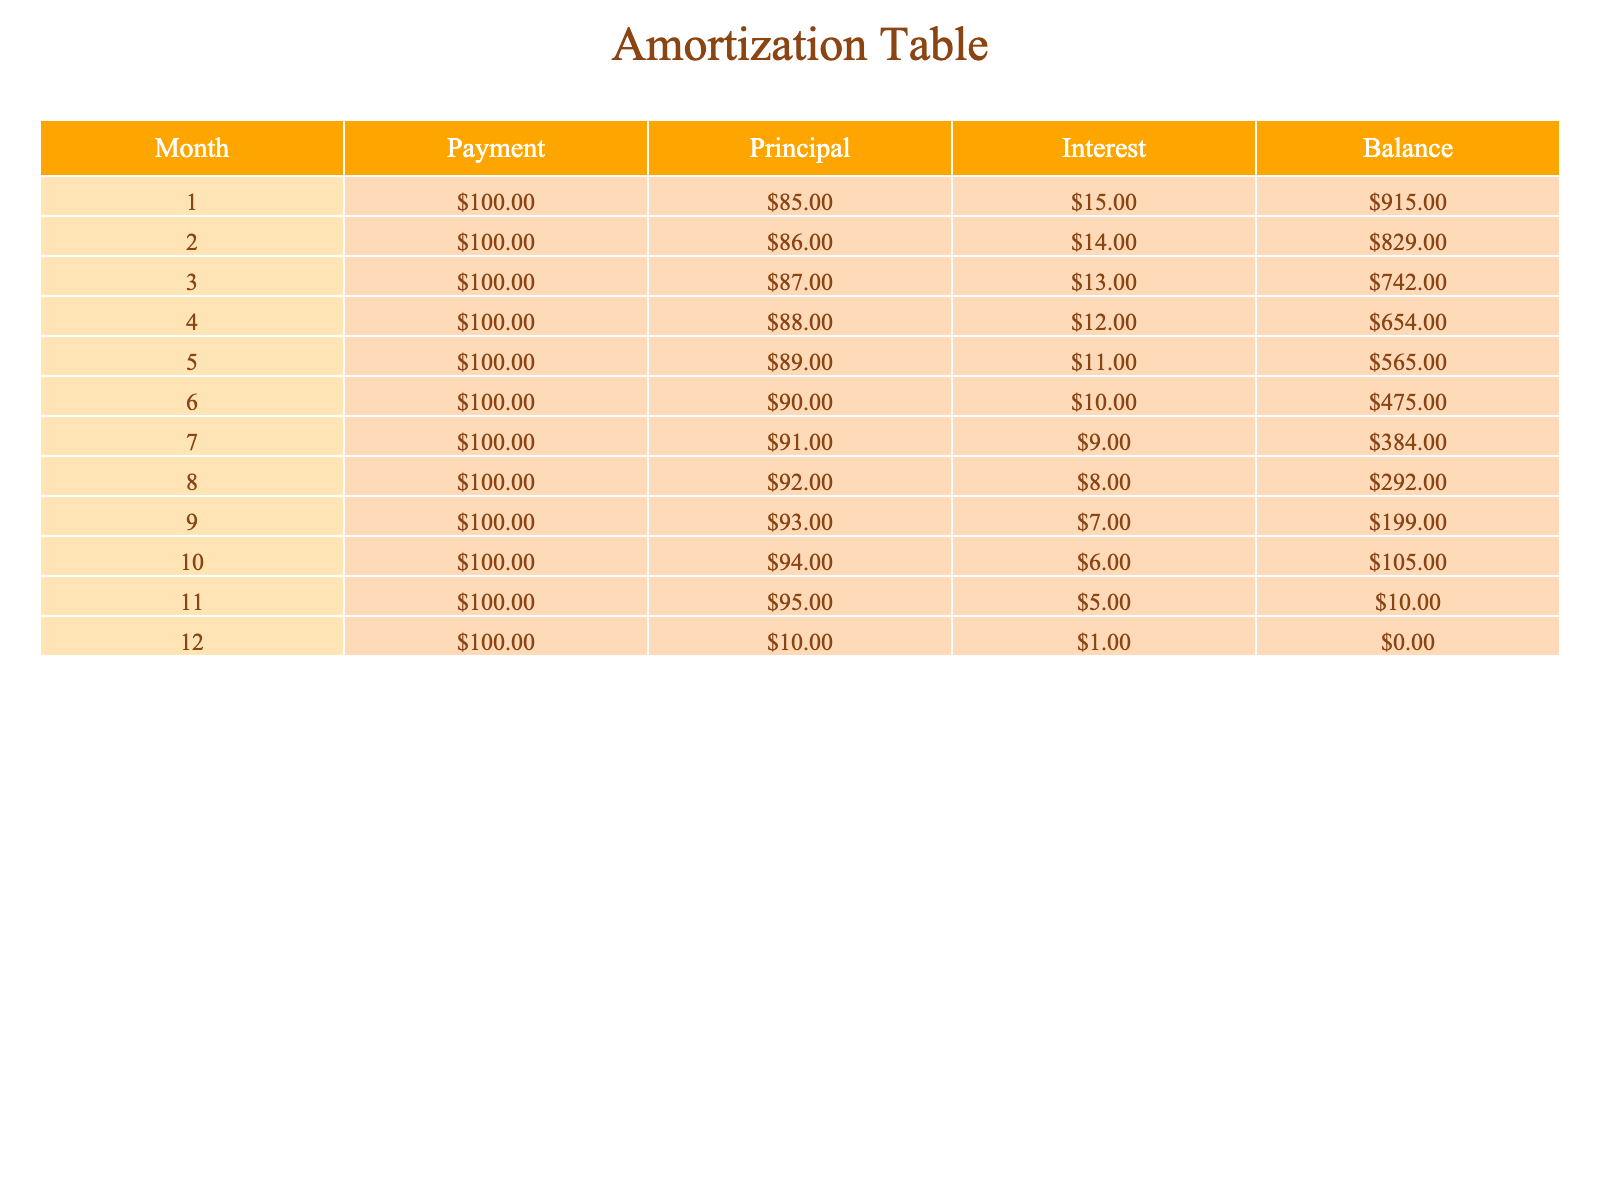What was the total payment made in the 12 months? To find the total payment, we multiply the monthly payment amount by the number of months: 100 (monthly payment) * 12 (months) = 1200.
Answer: 1200 What was the principal amount paid in month 6? According to the table, the principal amount paid in month 6 is 90.
Answer: 90 Is the interest amount paid in month 4 greater than that in month 8? In month 4, the interest amount is 12, and in month 8, it is 8. Since 12 is greater than 8, the answer is yes.
Answer: Yes What is the remaining balance after the payment in month 11? After the payment in month 11, the remaining balance in the table is 10.
Answer: 10 What was the average interest payment over the 12 months? To calculate the average interest, we sum the interest payments (15 + 14 + 13 + 12 + 11 + 10 + 9 + 8 + 7 + 6 + 5 + 1 = 91) and divide by the number of months (12): 91 / 12 = approximately 7.58.
Answer: 7.58 How much total principal was paid over the 12 months? The total principal is the sum of the principal amounts from all 12 months: (85 + 86 + 87 + 88 + 89 + 90 + 91 + 92 + 93 + 94 + 95 + 10 = 1080).
Answer: 1080 Was the payment in month 9 higher than in month 5? The payment in both months is 100; therefore, they are equal. The answer is no.
Answer: No How much interest was saved by month 12 compared to month 1? The interest paid in month 1 is 15, while in month 12 it is 1. The difference is 15 - 1 = 14.
Answer: 14 What was the principal amount paid in the last month? The principal amount paid in month 12 is 10 as shown in the table.
Answer: 10 